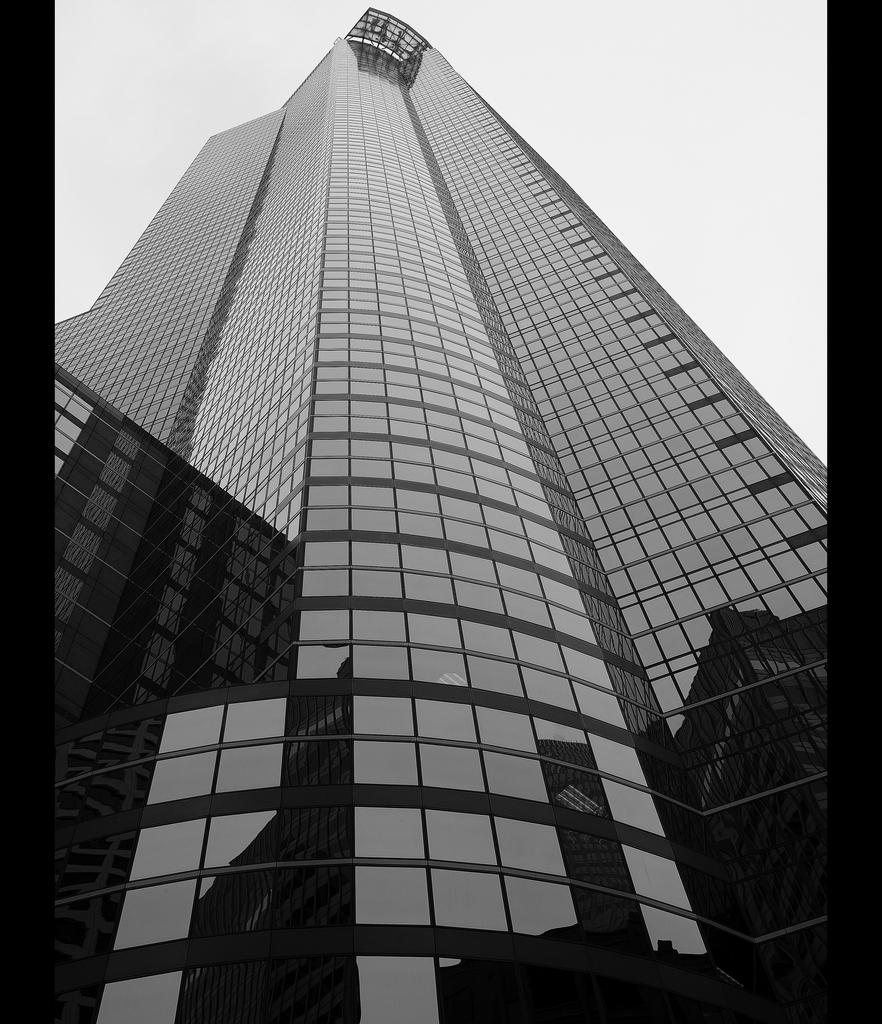What is the main subject in the center of the image? There is a skyscraper in the center of the image. How many cows are grazing in front of the skyscraper in the image? There are no cows present in the image; it features a skyscraper as the main subject. What is the value of the dime on the top of the skyscraper in the image? There is no dime present on the top of the skyscraper in the image. 